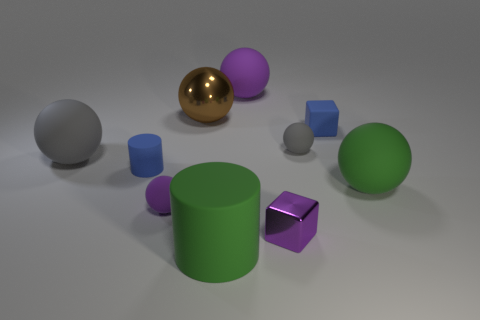Subtract all large purple matte spheres. How many spheres are left? 5 Subtract all purple spheres. How many spheres are left? 4 Subtract all blue spheres. Subtract all gray blocks. How many spheres are left? 6 Subtract all spheres. How many objects are left? 4 Subtract all green things. Subtract all large matte cylinders. How many objects are left? 7 Add 3 blocks. How many blocks are left? 5 Add 2 small matte cylinders. How many small matte cylinders exist? 3 Subtract 1 green cylinders. How many objects are left? 9 